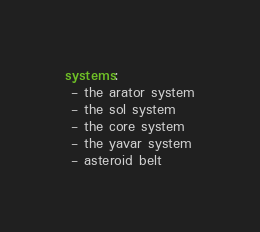Convert code to text. <code><loc_0><loc_0><loc_500><loc_500><_YAML_>systems:
 - the arator system
 - the sol system
 - the core system
 - the yavar system
 - asteroid belt</code> 